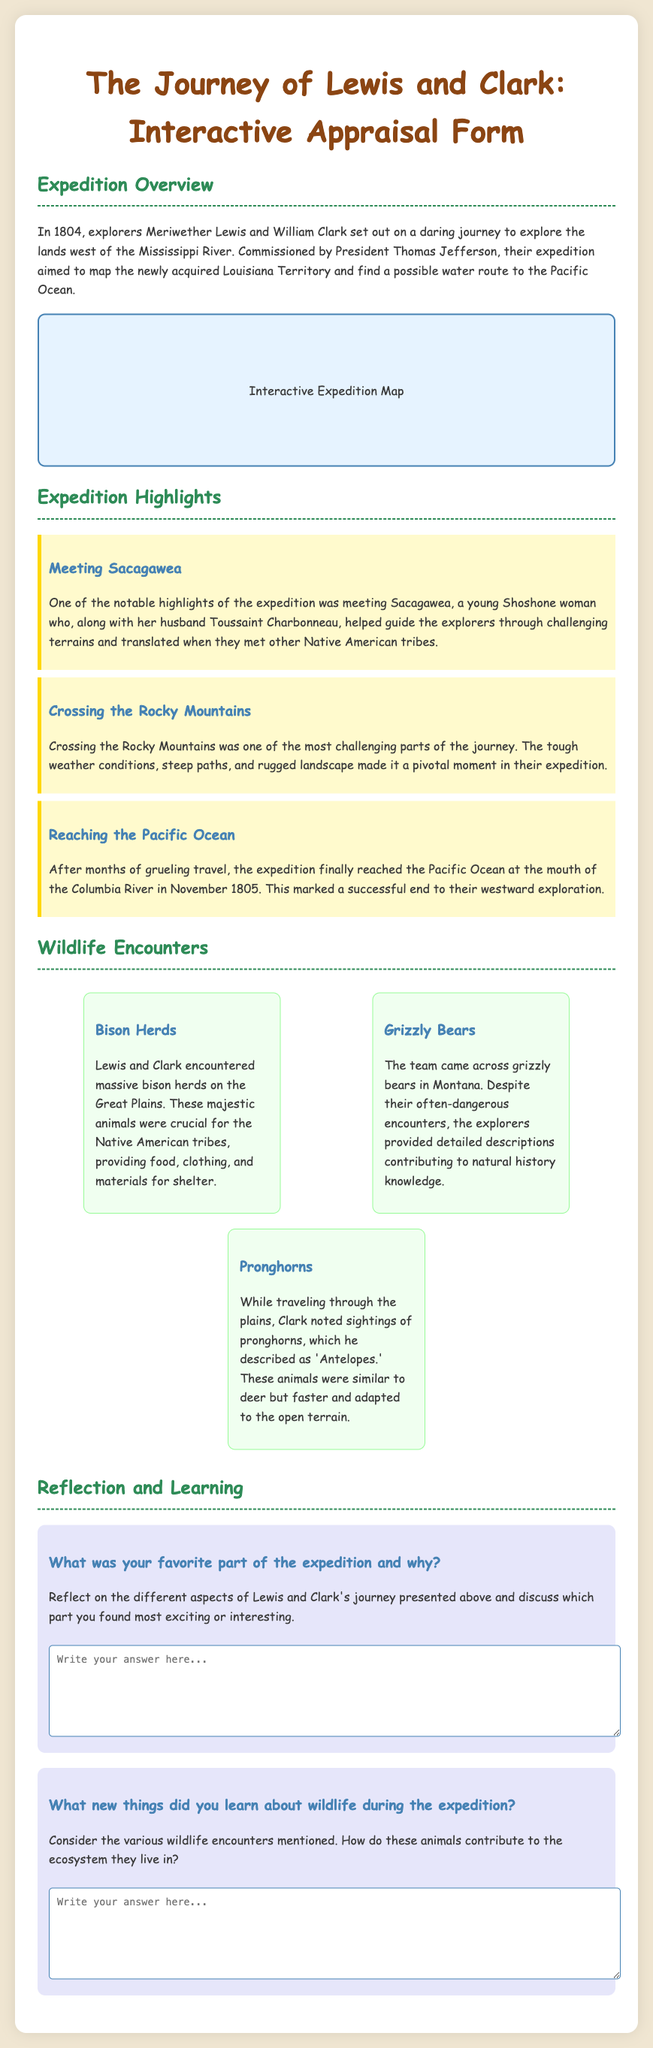What year did Lewis and Clark start their expedition? The document states that the expedition began in 1804.
Answer: 1804 Who did Lewis and Clark meet that helped them during their journey? The document mentions Sacagawea, who guided the explorers and translated for them.
Answer: Sacagawea What significant mountain range did Lewis and Clark cross? The highlights mention that crossing the Rocky Mountains was one of the challenging parts of the journey.
Answer: Rocky Mountains In what month and year did the expedition reach the Pacific Ocean? The document states that the expedition reached the Pacific Ocean in November 1805.
Answer: November 1805 Which animal did Lewis and Clark describe as 'Antelopes'? The explorers noted sightings of pronghorns and described them as 'Antelopes.'
Answer: Pronghorns What was one of the primary goals of the Lewis and Clark expedition? The document states that one goal was to find a possible water route to the Pacific Ocean.
Answer: Find a possible water route to the Pacific Ocean What unique feature is included in the document to enhance interactivity? The document features an "Interactive Expedition Map" as part of the content.
Answer: Interactive Expedition Map What role did Sacagawea serve during the expedition? The document explains she helped guide the explorers through difficult terrains.
Answer: Guide What type of document is this appraisal form related to? The document is specifically related to the 'Journey of Lewis and Clark.'
Answer: Journey of Lewis and Clark 